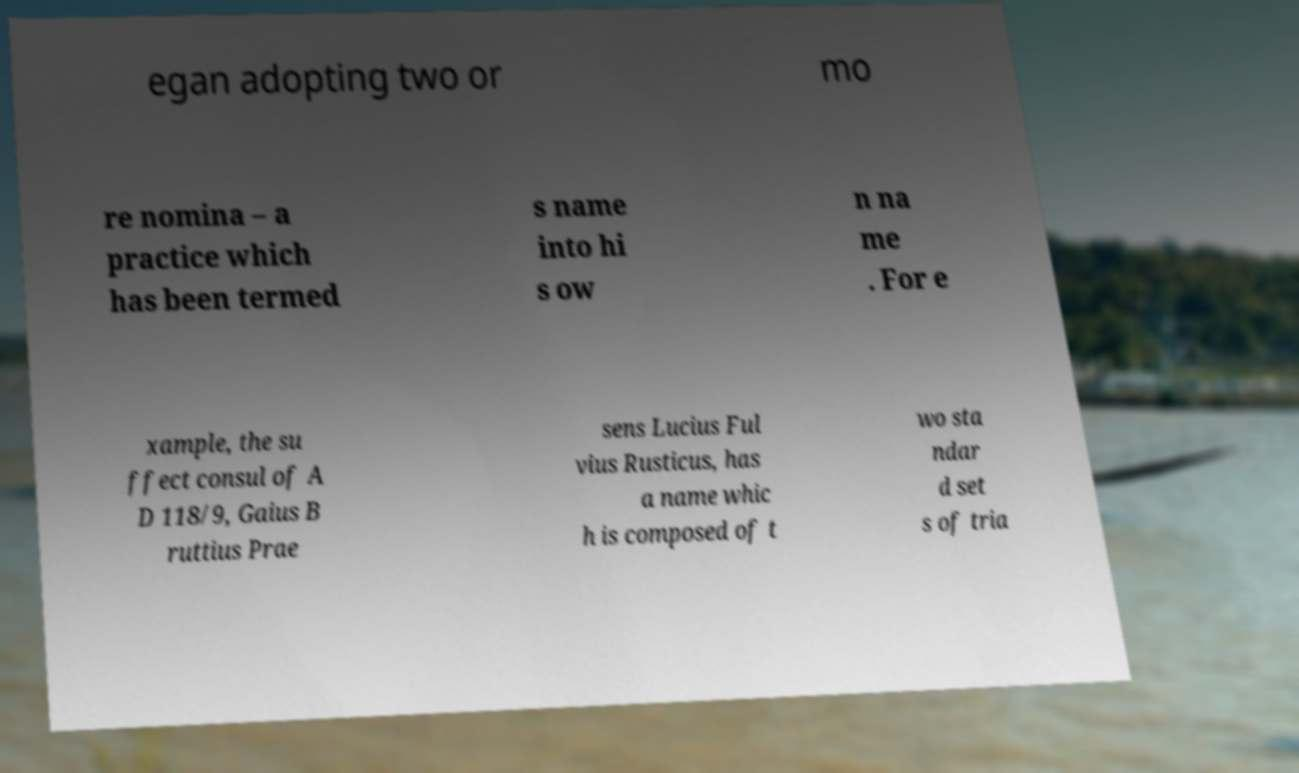I need the written content from this picture converted into text. Can you do that? egan adopting two or mo re nomina – a practice which has been termed s name into hi s ow n na me . For e xample, the su ffect consul of A D 118/9, Gaius B ruttius Prae sens Lucius Ful vius Rusticus, has a name whic h is composed of t wo sta ndar d set s of tria 